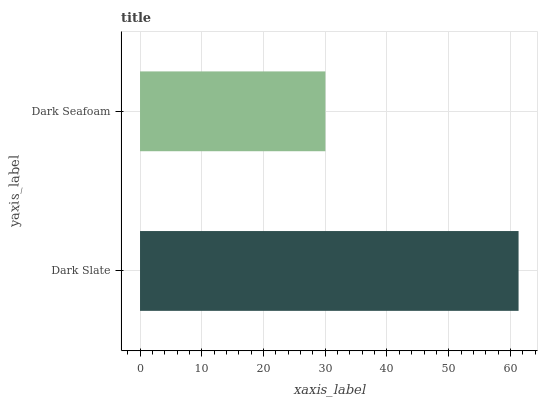Is Dark Seafoam the minimum?
Answer yes or no. Yes. Is Dark Slate the maximum?
Answer yes or no. Yes. Is Dark Seafoam the maximum?
Answer yes or no. No. Is Dark Slate greater than Dark Seafoam?
Answer yes or no. Yes. Is Dark Seafoam less than Dark Slate?
Answer yes or no. Yes. Is Dark Seafoam greater than Dark Slate?
Answer yes or no. No. Is Dark Slate less than Dark Seafoam?
Answer yes or no. No. Is Dark Slate the high median?
Answer yes or no. Yes. Is Dark Seafoam the low median?
Answer yes or no. Yes. Is Dark Seafoam the high median?
Answer yes or no. No. Is Dark Slate the low median?
Answer yes or no. No. 